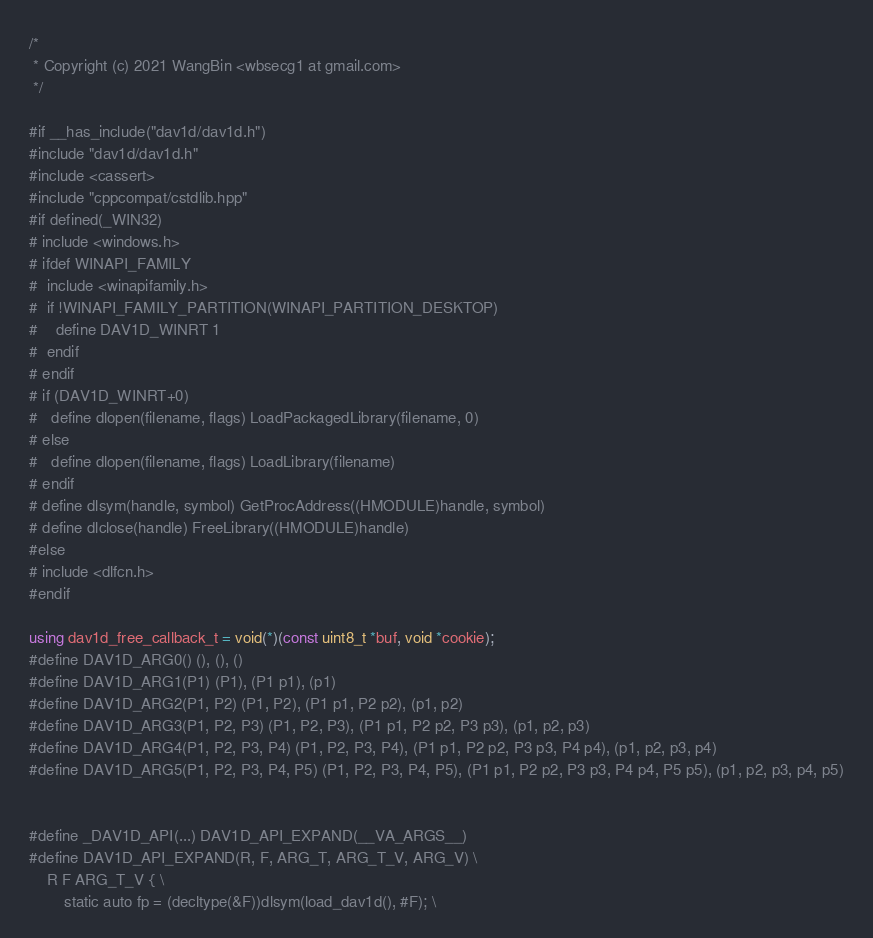Convert code to text. <code><loc_0><loc_0><loc_500><loc_500><_C++_>/*
 * Copyright (c) 2021 WangBin <wbsecg1 at gmail.com>
 */

#if __has_include("dav1d/dav1d.h")
#include "dav1d/dav1d.h"
#include <cassert>
#include "cppcompat/cstdlib.hpp"
#if defined(_WIN32)
# include <windows.h>
# ifdef WINAPI_FAMILY
#  include <winapifamily.h>
#  if !WINAPI_FAMILY_PARTITION(WINAPI_PARTITION_DESKTOP)
#    define DAV1D_WINRT 1
#  endif
# endif
# if (DAV1D_WINRT+0)
#   define dlopen(filename, flags) LoadPackagedLibrary(filename, 0)
# else
#   define dlopen(filename, flags) LoadLibrary(filename)
# endif
# define dlsym(handle, symbol) GetProcAddress((HMODULE)handle, symbol)
# define dlclose(handle) FreeLibrary((HMODULE)handle)
#else
# include <dlfcn.h>
#endif

using dav1d_free_callback_t = void(*)(const uint8_t *buf, void *cookie);
#define DAV1D_ARG0() (), (), ()
#define DAV1D_ARG1(P1) (P1), (P1 p1), (p1)
#define DAV1D_ARG2(P1, P2) (P1, P2), (P1 p1, P2 p2), (p1, p2)
#define DAV1D_ARG3(P1, P2, P3) (P1, P2, P3), (P1 p1, P2 p2, P3 p3), (p1, p2, p3)
#define DAV1D_ARG4(P1, P2, P3, P4) (P1, P2, P3, P4), (P1 p1, P2 p2, P3 p3, P4 p4), (p1, p2, p3, p4)
#define DAV1D_ARG5(P1, P2, P3, P4, P5) (P1, P2, P3, P4, P5), (P1 p1, P2 p2, P3 p3, P4 p4, P5 p5), (p1, p2, p3, p4, p5)


#define _DAV1D_API(...) DAV1D_API_EXPAND(__VA_ARGS__)
#define DAV1D_API_EXPAND(R, F, ARG_T, ARG_T_V, ARG_V) \
    R F ARG_T_V { \
        static auto fp = (decltype(&F))dlsym(load_dav1d(), #F); \</code> 